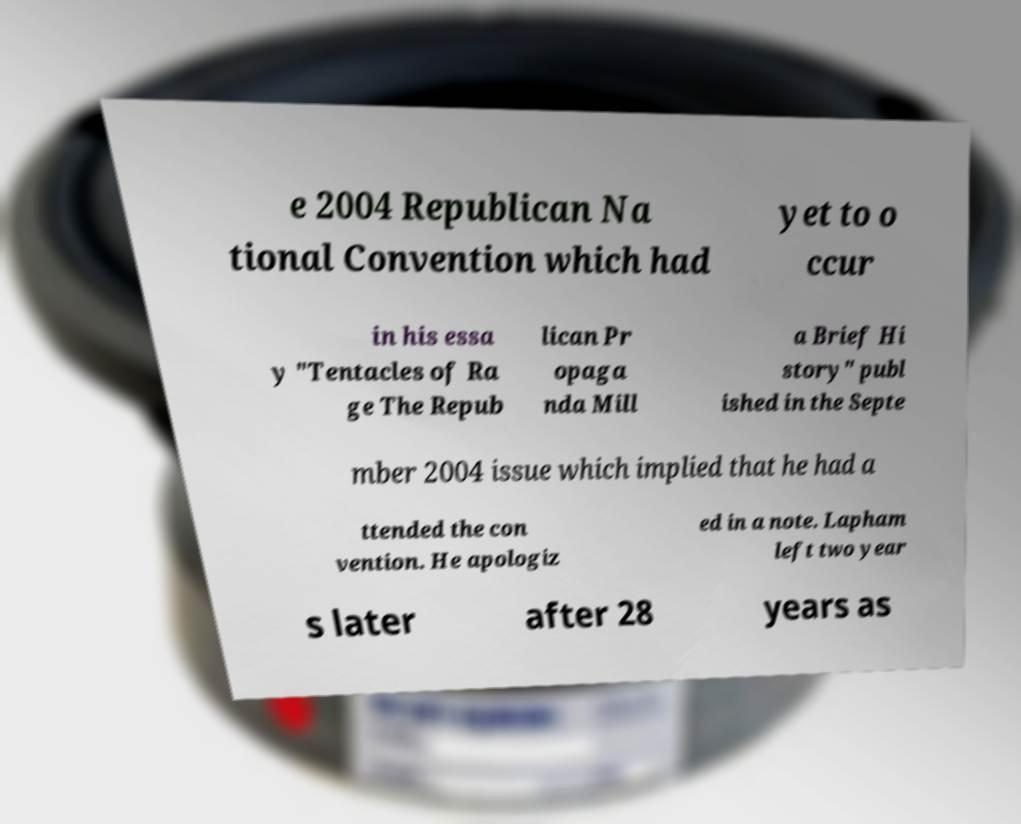Could you extract and type out the text from this image? e 2004 Republican Na tional Convention which had yet to o ccur in his essa y "Tentacles of Ra ge The Repub lican Pr opaga nda Mill a Brief Hi story" publ ished in the Septe mber 2004 issue which implied that he had a ttended the con vention. He apologiz ed in a note. Lapham left two year s later after 28 years as 